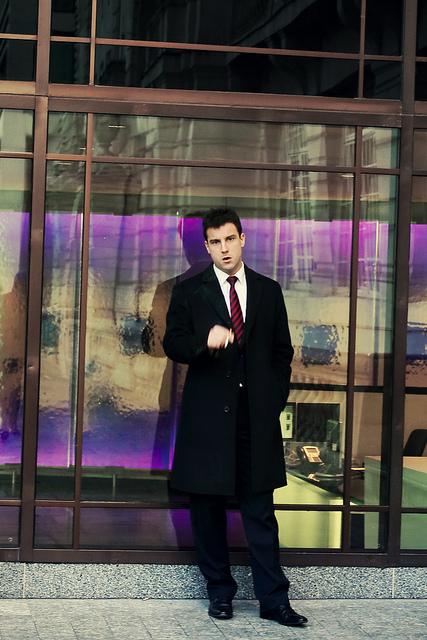Is this man wearing a suit?
Quick response, please. Yes. What is in the man's right hand?
Give a very brief answer. Cigarette. Is the man standing in front of a bar?
Short answer required. Yes. 